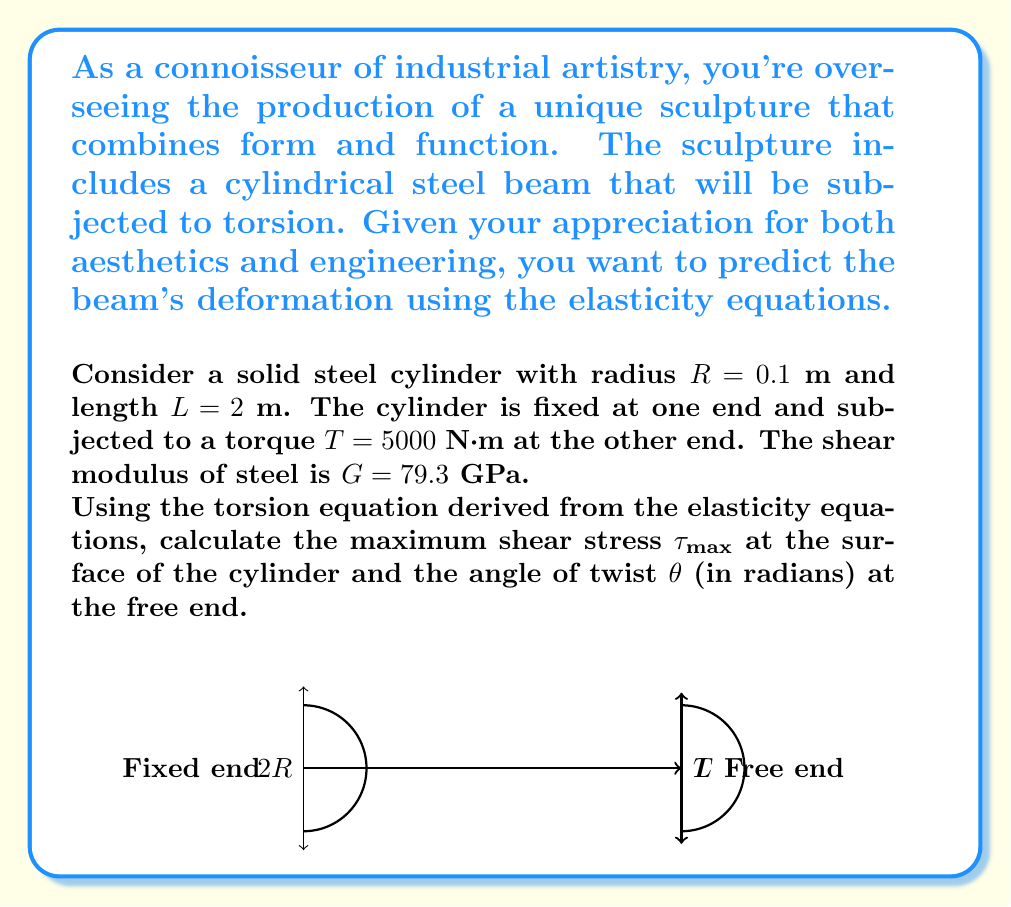Solve this math problem. Let's approach this problem step-by-step using the elasticity equations for torsion:

1) For a solid circular shaft, the maximum shear stress $\tau_{max}$ occurs at the surface and is given by:

   $$\tau_{max} = \frac{Tr}{J}$$

   where $T$ is the applied torque, $r$ is the radius, and $J$ is the polar moment of inertia.

2) For a solid circular shaft, $J = \frac{\pi R^4}{2}$. Let's calculate this:

   $$J = \frac{\pi (0.1\text{ m})^4}{2} = 1.5708 \times 10^{-5} \text{ m}^4$$

3) Now we can calculate $\tau_{max}$:

   $$\tau_{max} = \frac{5000\text{ N·m} \times 0.1\text{ m}}{1.5708 \times 10^{-5} \text{ m}^4} = 31.831 \times 10^6 \text{ Pa} = 31.831 \text{ MPa}$$

4) For the angle of twist $\theta$, we use the equation:

   $$\theta = \frac{TL}{GJ}$$

   where $L$ is the length of the cylinder and $G$ is the shear modulus.

5) Substituting the values:

   $$\theta = \frac{5000\text{ N·m} \times 2\text{ m}}{79.3 \times 10^9 \text{ Pa} \times 1.5708 \times 10^{-5} \text{ m}^4} = 0.08032 \text{ radians}$$

Thus, we have calculated both the maximum shear stress and the angle of twist for the cylindrical beam.
Answer: $\tau_{max} = 31.831 \text{ MPa}$, $\theta = 0.08032 \text{ radians}$ 